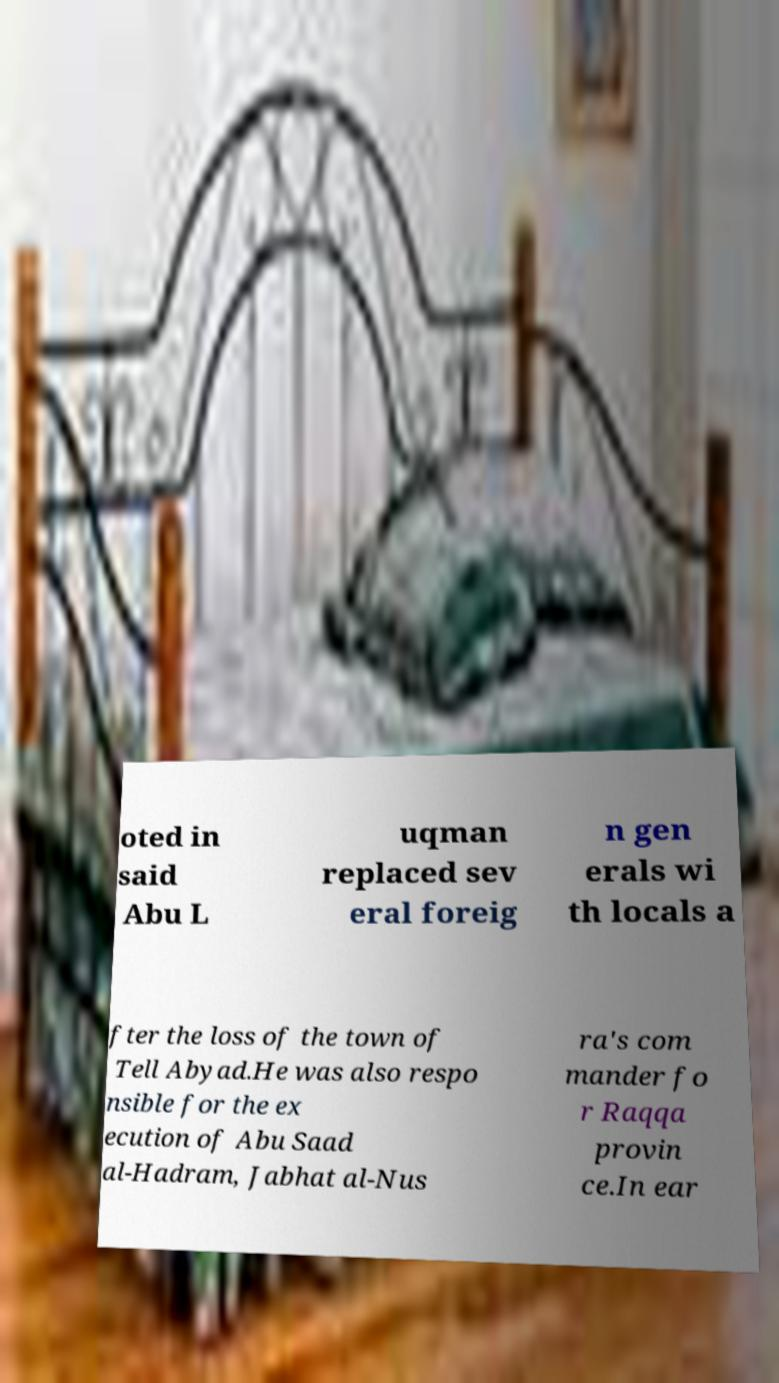Please identify and transcribe the text found in this image. oted in said Abu L uqman replaced sev eral foreig n gen erals wi th locals a fter the loss of the town of Tell Abyad.He was also respo nsible for the ex ecution of Abu Saad al-Hadram, Jabhat al-Nus ra's com mander fo r Raqqa provin ce.In ear 